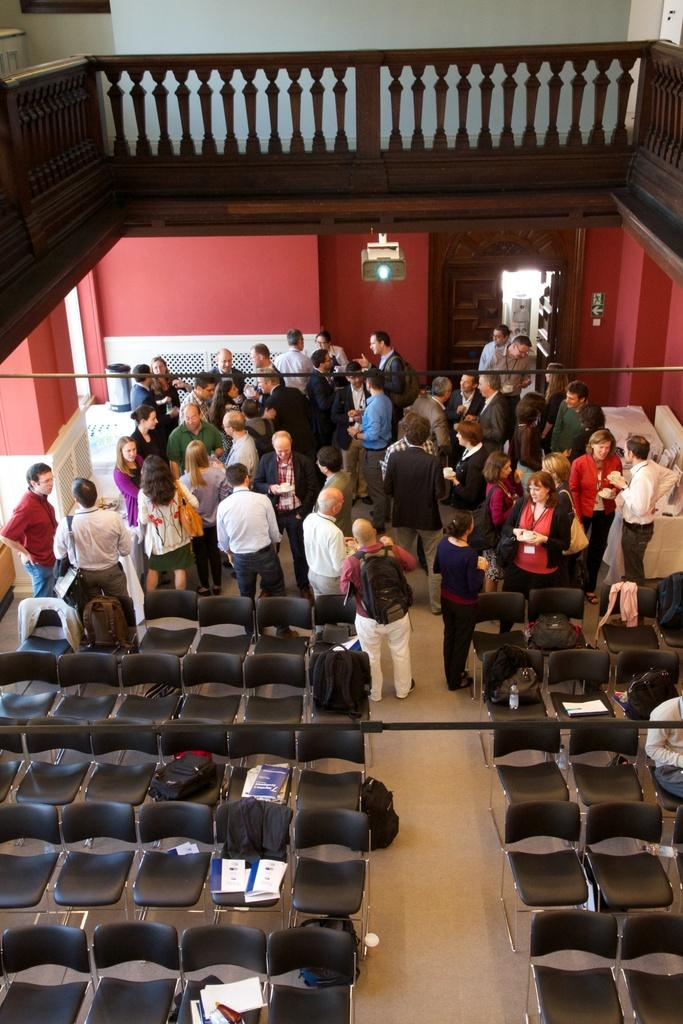What is the main subject of the image? The main subject of the image is a group of people standing. What type of furniture is present in the image? There are black chairs in the image. Are the chairs occupied or empty? The chairs are left empty. What type of blade can be seen cutting through the chairs in the image? There is no blade present in the image, and the chairs are not being cut. Is there a truck visible in the image? No, there is no truck present in the image. 